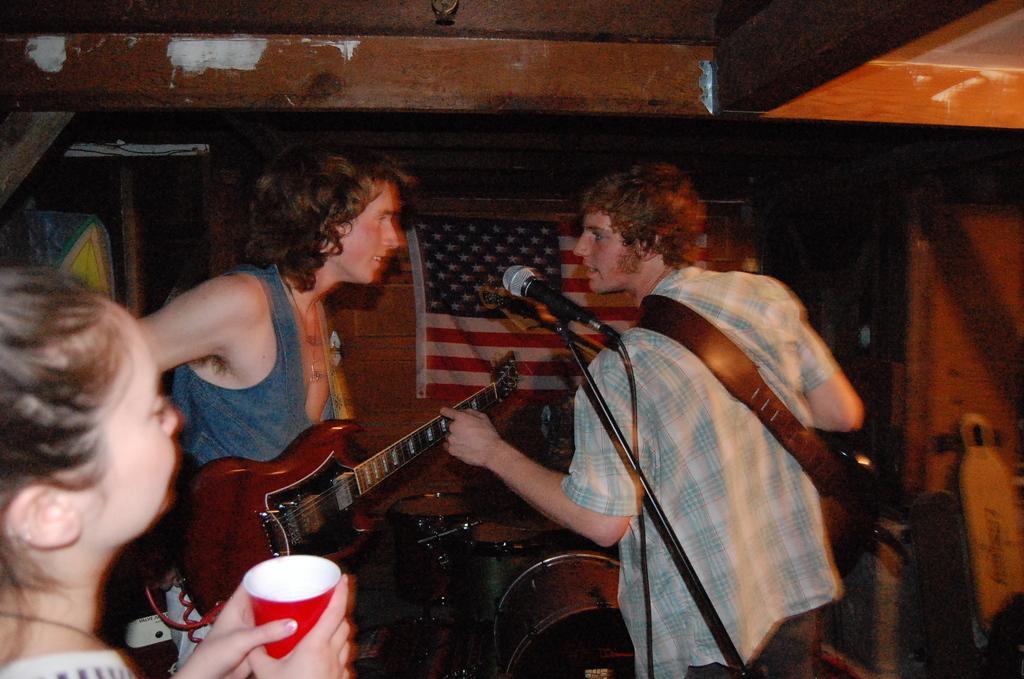Describe this image in one or two sentences. In this image, there is an inside view of a room. There are three persons wearing colorful clothes. There is a person who is on the left side of the image wearing a guitar. There is a person who is in the bottom left of the image holding a cup with her hands. There is a mic in the center of the image. 